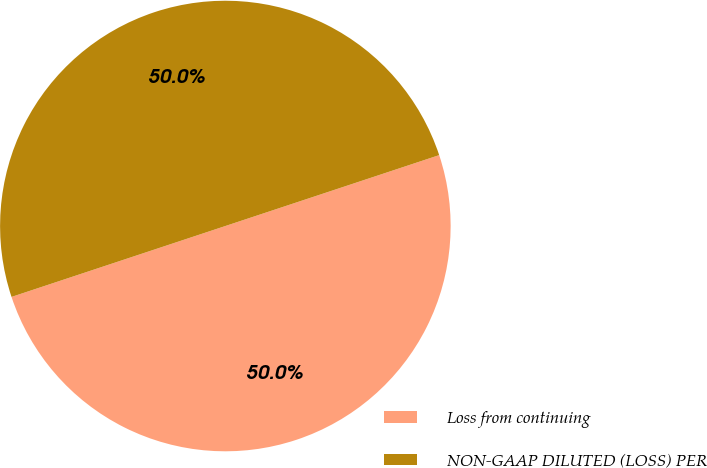Convert chart to OTSL. <chart><loc_0><loc_0><loc_500><loc_500><pie_chart><fcel>Loss from continuing<fcel>NON-GAAP DILUTED (LOSS) PER<nl><fcel>50.0%<fcel>50.0%<nl></chart> 